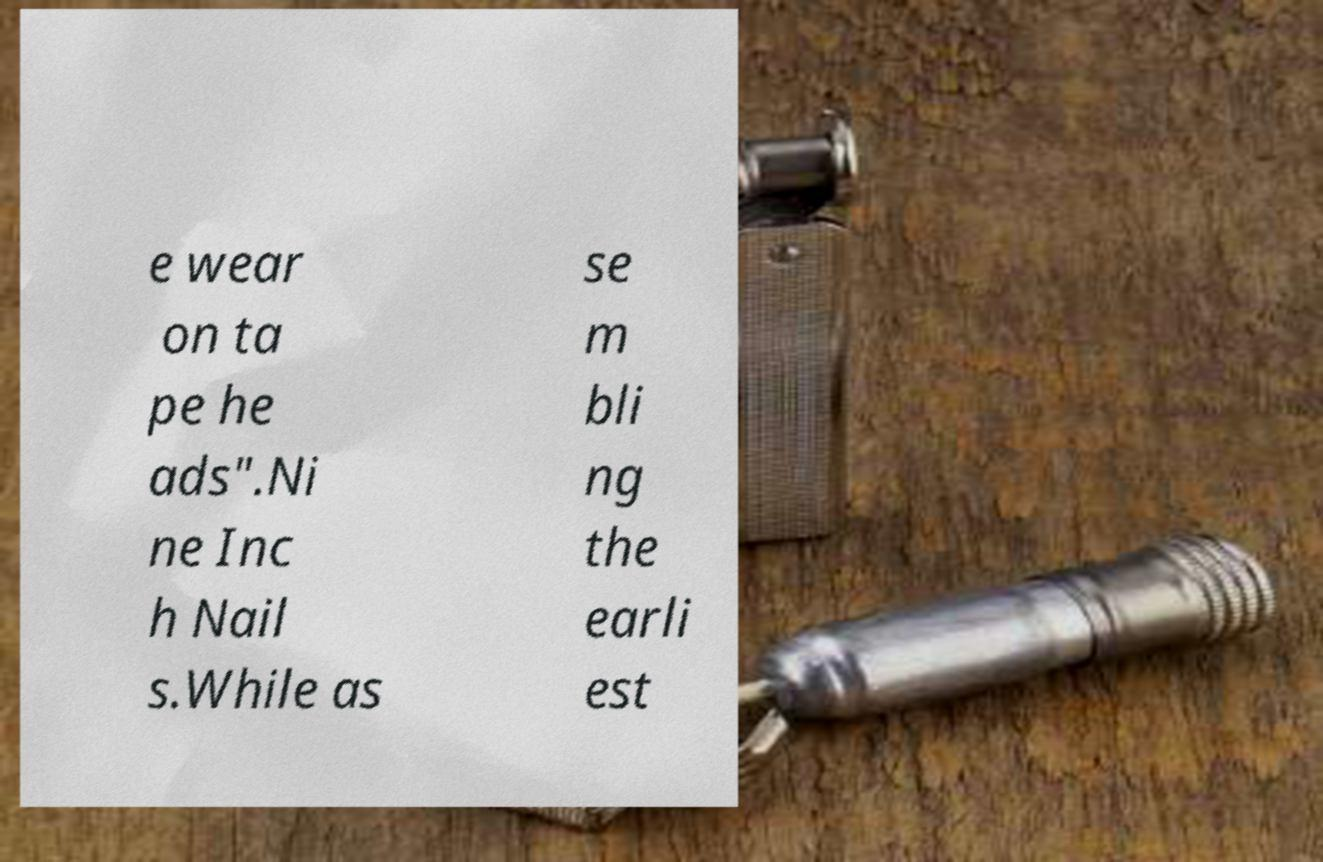Can you accurately transcribe the text from the provided image for me? e wear on ta pe he ads".Ni ne Inc h Nail s.While as se m bli ng the earli est 